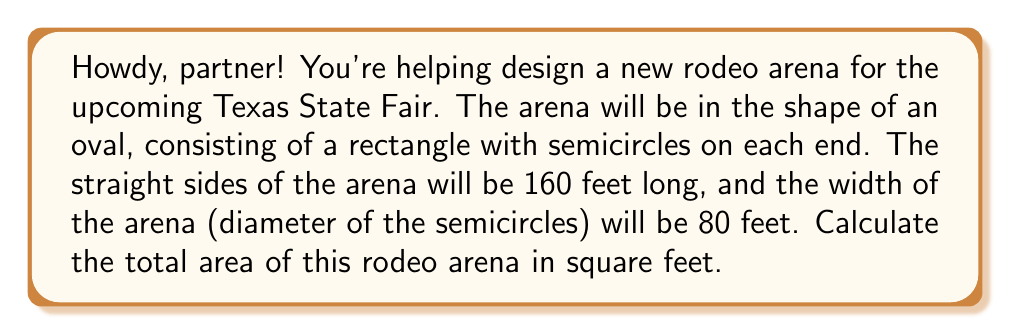Provide a solution to this math problem. Let's break this down step-by-step, cowboy:

1) The arena consists of two parts: a rectangle and two semicircles.

2) For the rectangle:
   - Length = 160 feet
   - Width = 80 feet
   - Area of rectangle = $160 \times 80 = 12,800$ square feet

3) For the semicircles:
   - Diameter = 80 feet, so radius = 40 feet
   - Area of a full circle = $\pi r^2$
   - Area of one semicircle = $\frac{1}{2} \pi r^2$
   - Area of two semicircles = $\pi r^2$
   
   $$\text{Area of semicircles} = \pi (40)^2 = 1600\pi \approx 5,026.55 \text{ square feet}$$

4) Total area:
   $$\text{Total Area} = \text{Area of rectangle} + \text{Area of semicircles}$$
   $$\text{Total Area} = 12,800 + 1600\pi$$

5) Simplifying:
   $$\text{Total Area} = 12,800 + 1600\pi \approx 17,826.55 \text{ square feet}$$

[asy]
unitsize(0.03feet);
fill((-80,-40)--(80,-40)--(80,40)--(-80,40)--cycle, lightgray);
fill(arc((80,0),40,90,270), lightgray);
fill(arc((-80,0),40,-90,90), lightgray);
draw((-80,-40)--(80,-40)--(80,40)--(-80,40)--cycle);
draw(arc((80,0),40,90,270));
draw(arc((-80,0),40,-90,90));
label("160 feet", (0,-50));
label("80 feet", (90,0), E);
[/asy]
Answer: $$\text{Total Area} = 12,800 + 1600\pi \approx 17,826.55 \text{ square feet}$$ 